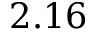Convert formula to latex. <formula><loc_0><loc_0><loc_500><loc_500>2 . 1 6</formula> 